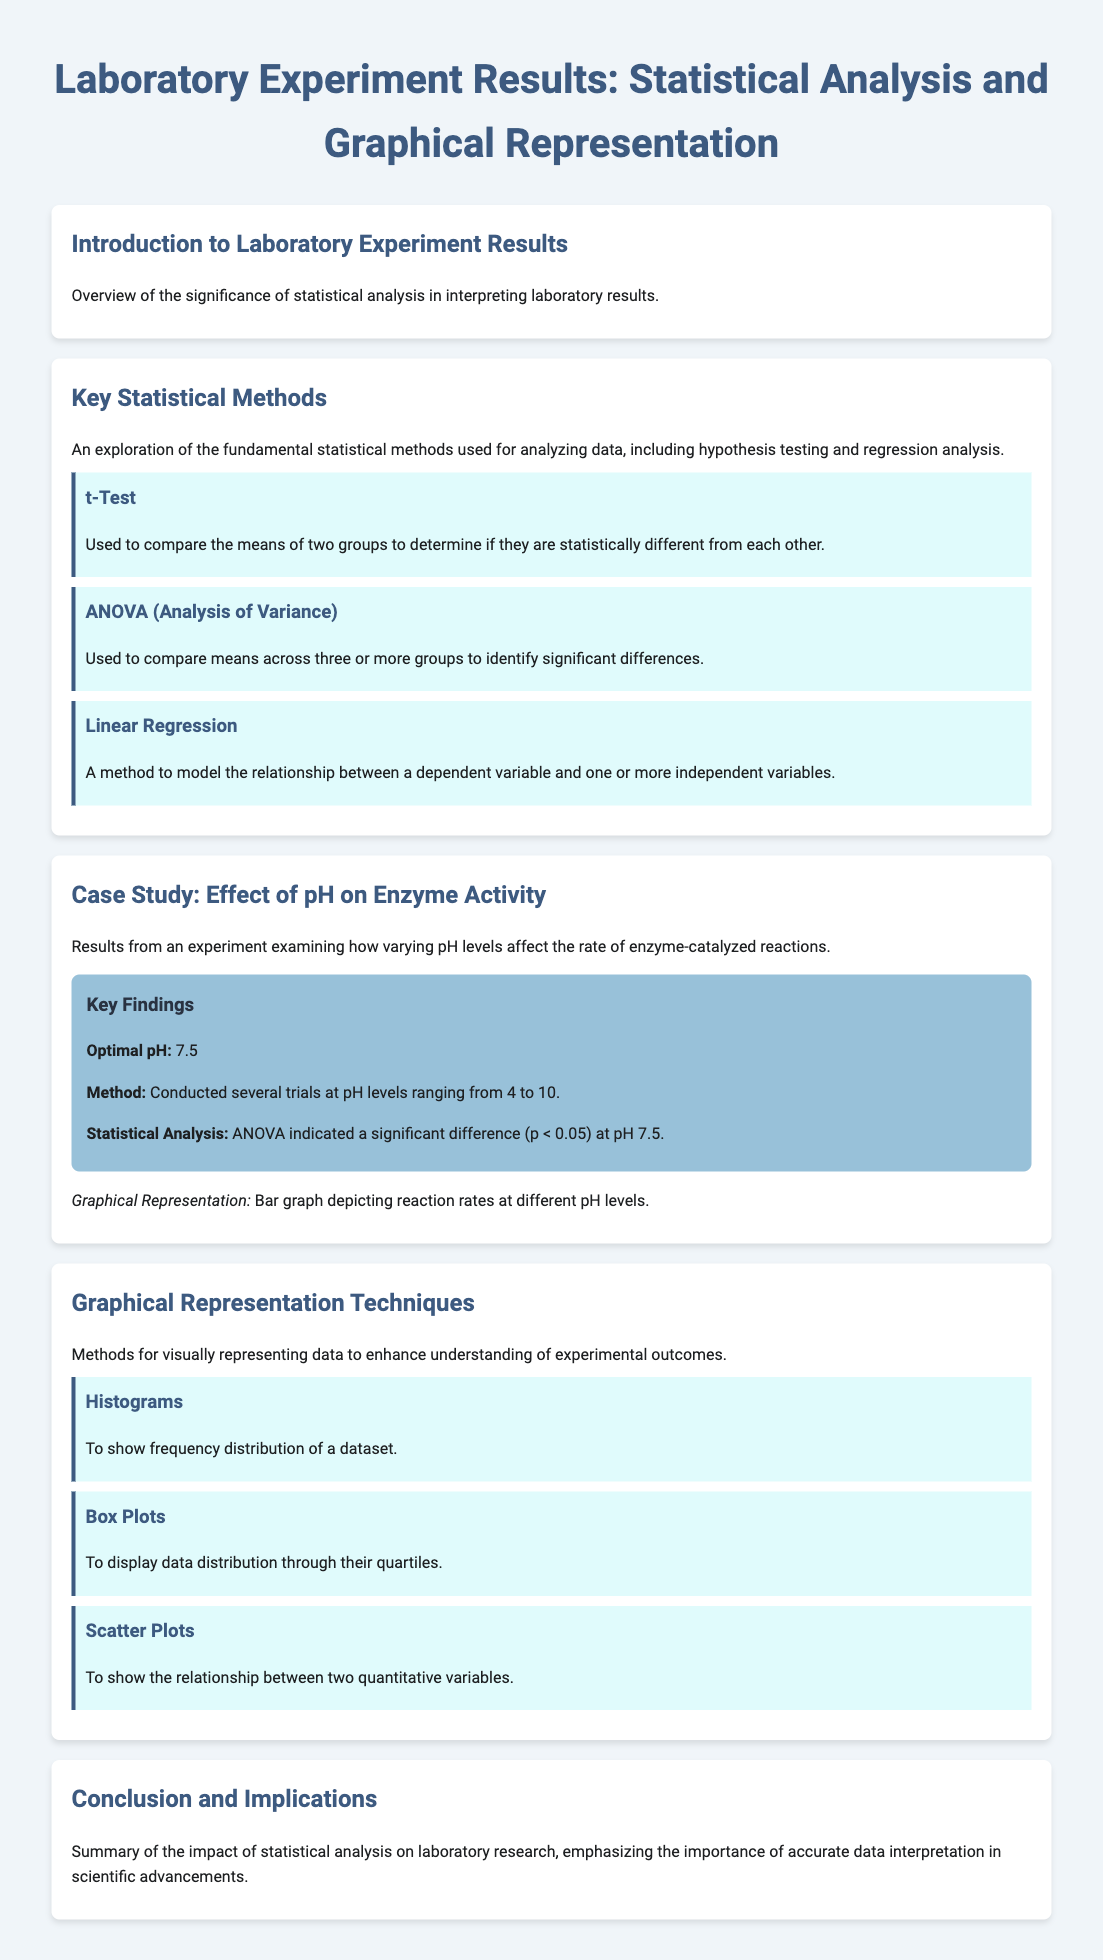What is the optimal pH for enzyme activity? The optimal pH is identified from the experimental results under the case study, which specifies the level that yields the highest enzyme activity.
Answer: 7.5 Which statistical analysis was used in the case study? The statistical method mentioned in the findings section helps to determine whether there are significant differences in the data collected from different groups.
Answer: ANOVA What is the range of pH levels tested in the experiment? The range provided indicates the minimum and maximum pH values that were examined during the trials.
Answer: 4 to 10 What type of graph is suggested for representing reaction rates at different pH levels? This is mentioned in the findings section, indicating the type of visual representation that can effectively display the experiment's results.
Answer: Bar graph What method is used to compare the means of two groups? The document specifies various statistical methods, among which one specifically deals with two-group comparisons, described thoroughly.
Answer: t-Test Which graphical representation technique shows relationships between two quantitative variables? This question relates to the type of graph used to visually represent the correlation between two data points identified in the section about graphical techniques.
Answer: Scatter Plots What is the main significance of statistical analysis in laboratory results? This is summarized in the introduction which highlights the importance of data interpretation in scientific research.
Answer: Interpretation What statistical method helps identify significant differences across three or more groups? The explanation about statistical techniques includes methods suited for analyzing data when dealing with multiple groups, clarifying its purpose.
Answer: ANOVA What color background is used for the findings section? The findings section is visually distinguished by a specific background color, as stated in the document's styling.
Answer: Light blue (or #98c1d9) 